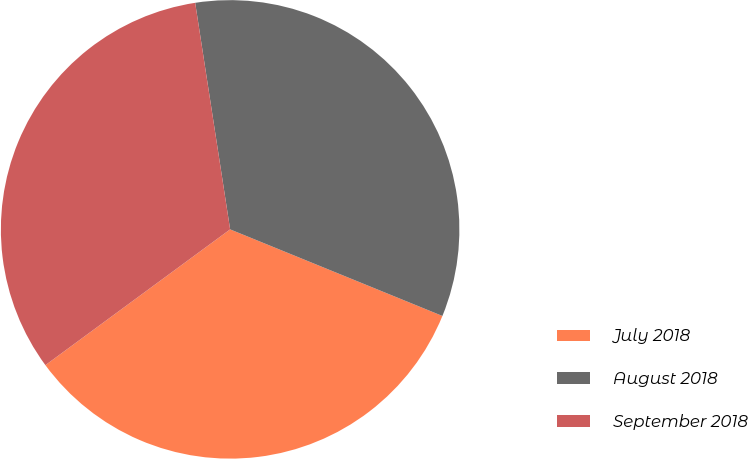Convert chart to OTSL. <chart><loc_0><loc_0><loc_500><loc_500><pie_chart><fcel>July 2018<fcel>August 2018<fcel>September 2018<nl><fcel>33.75%<fcel>33.6%<fcel>32.65%<nl></chart> 